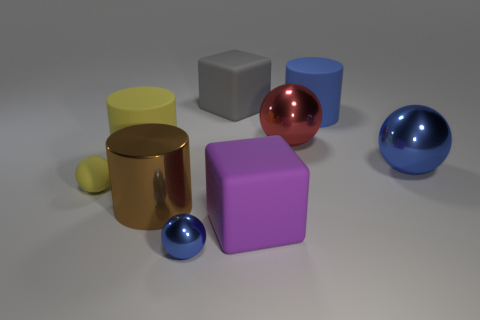Is there any pattern in the arrangement of these objects? There's no discernible pattern to their arrangement; they seem to be placed randomly on a flat surface. This lack of pattern provides an interesting study in how various geometric shapes and colors interact without any apparent order. 